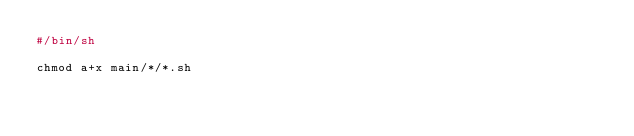<code> <loc_0><loc_0><loc_500><loc_500><_Bash_>#/bin/sh

chmod a+x main/*/*.sh</code> 